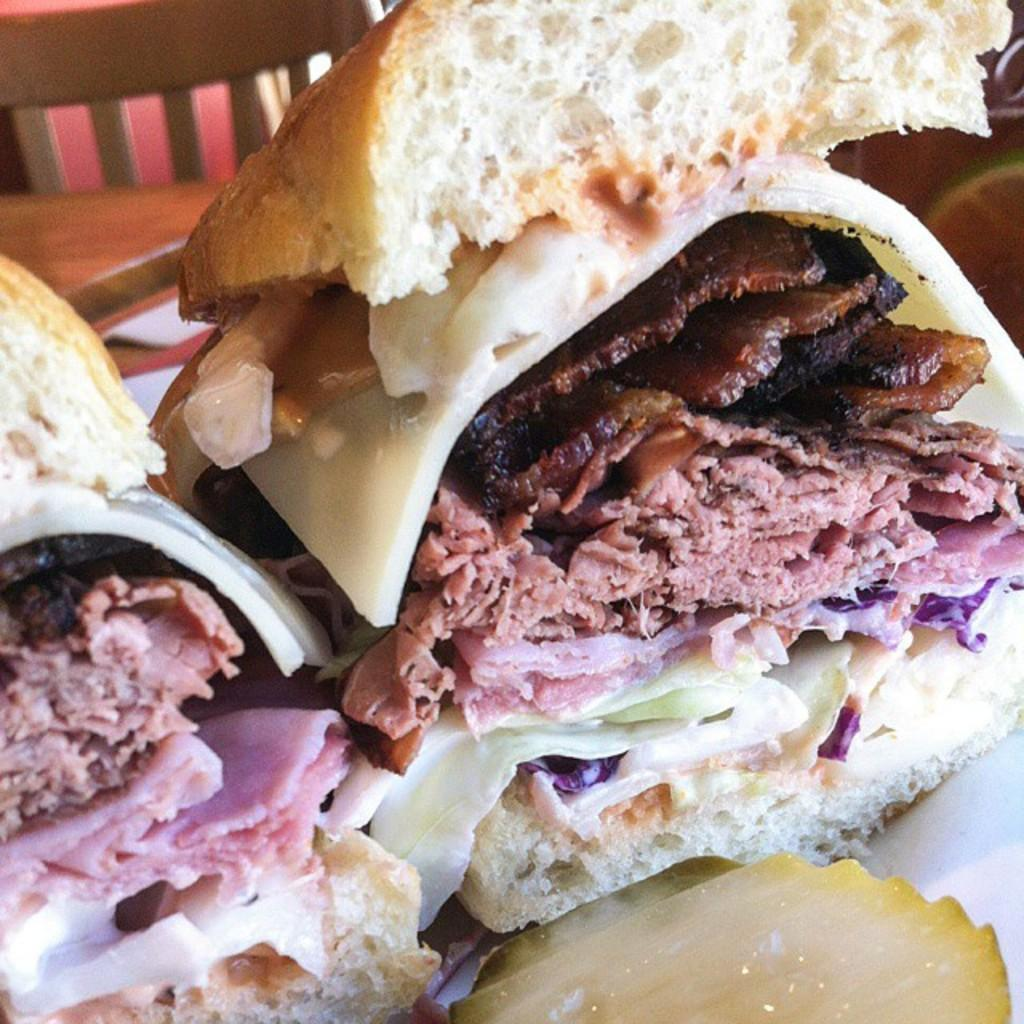What type of food is depicted in the image? The image contains burger slices, which include bread, cheese, meat, and vegetables. Can you describe the components of the burger slices? Yes, there is bread, cheese, meat, and vegetables in the image. What type of cheese is used in the burger slices? The facts provided do not specify the type of cheese used in the burger slices. What is your mom doing in the image? There is no reference to a mom or any person in the image; it only contains burger slices and their components. 